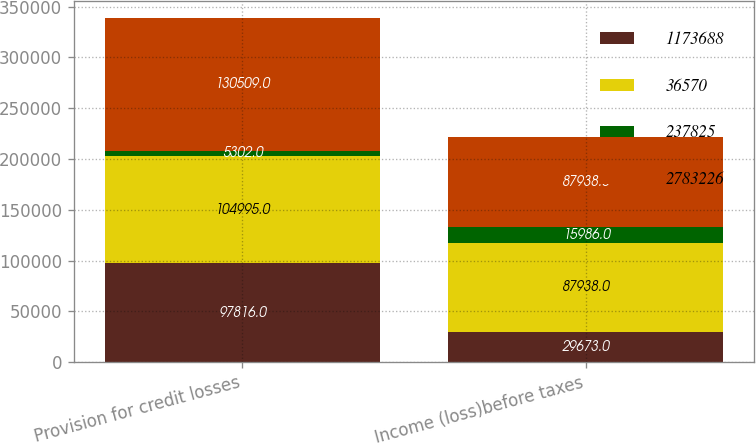Convert chart to OTSL. <chart><loc_0><loc_0><loc_500><loc_500><stacked_bar_chart><ecel><fcel>Provision for credit losses<fcel>Income (loss)before taxes<nl><fcel>1.17369e+06<fcel>97816<fcel>29673<nl><fcel>36570<fcel>104995<fcel>87938<nl><fcel>237825<fcel>5302<fcel>15986<nl><fcel>2.78323e+06<fcel>130509<fcel>87938<nl></chart> 